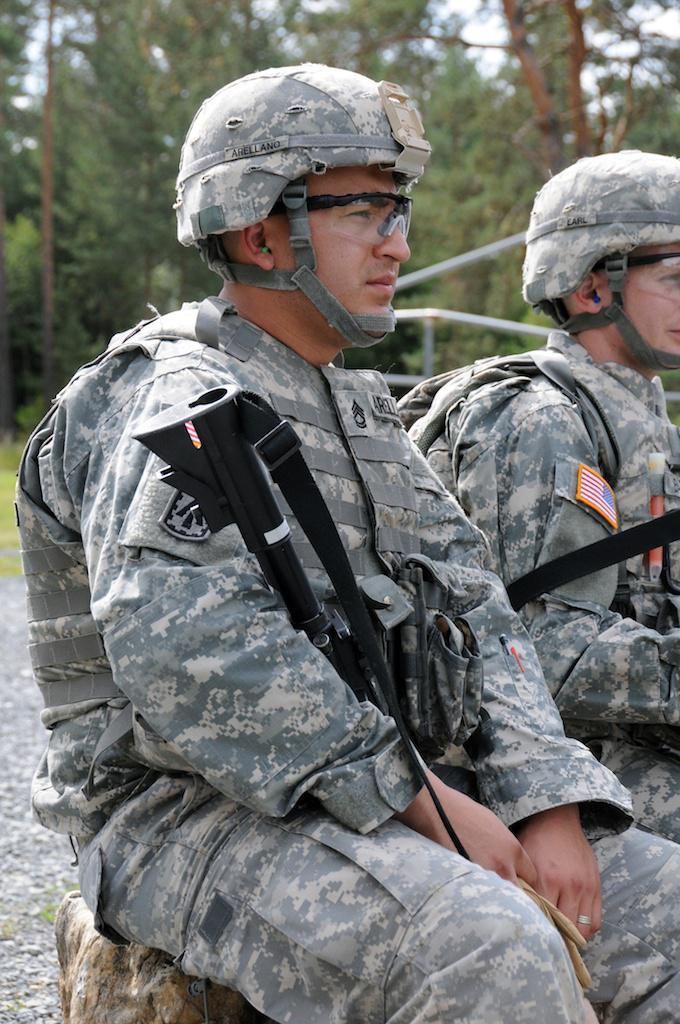How many people are in the image? There are two men in the image. What are the men doing in the image? The men are sitting. What protective gear are the men wearing? The men are wearing helmets and glasses. What can be seen in the background of the image? There are trees and grass in the background of the image. Where is the robin perched in the image? There is no robin present in the image. What type of crate is being used to frame the scene in the image? There is no crate or framing device present in the image. 